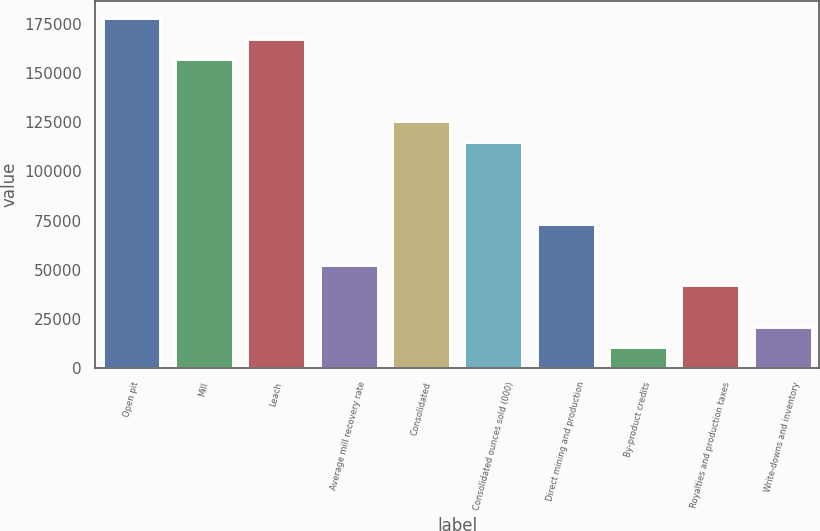Convert chart. <chart><loc_0><loc_0><loc_500><loc_500><bar_chart><fcel>Open pit<fcel>Mill<fcel>Leach<fcel>Average mill recovery rate<fcel>Consolidated<fcel>Consolidated ounces sold (000)<fcel>Direct mining and production<fcel>By-product credits<fcel>Royalties and production taxes<fcel>Write-downs and inventory<nl><fcel>178097<fcel>157144<fcel>167621<fcel>52381.5<fcel>125716<fcel>115239<fcel>73334.1<fcel>10476.3<fcel>41905.2<fcel>20952.6<nl></chart> 